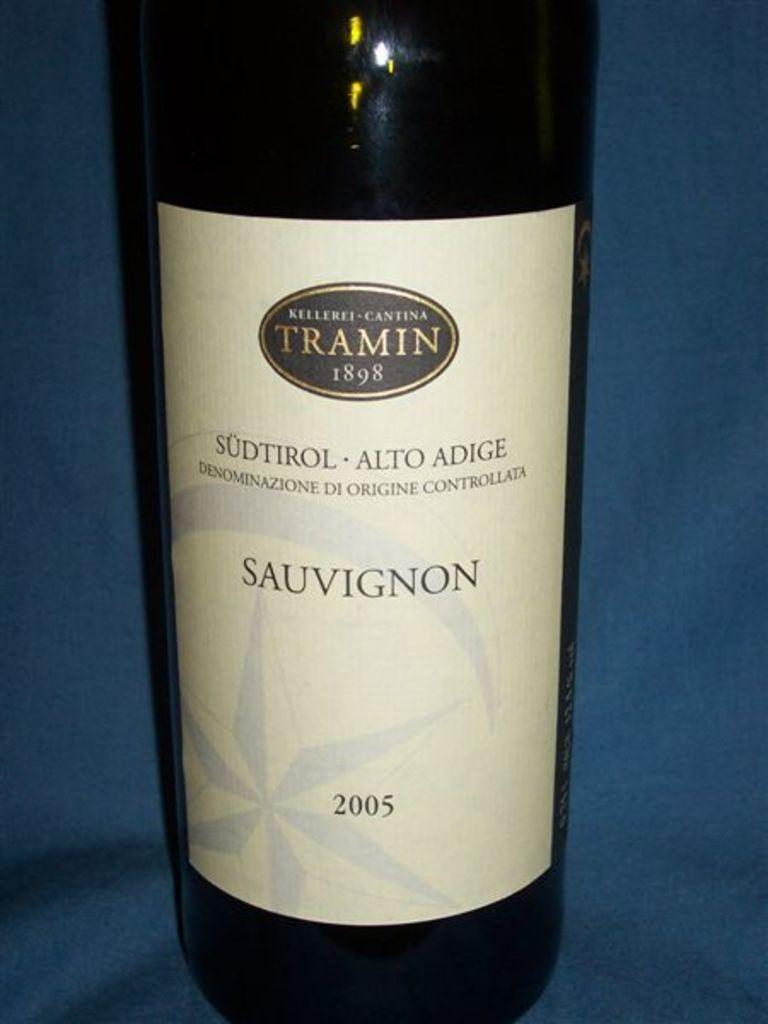<image>
Present a compact description of the photo's key features. A bottle of 2005 TRAMIN 1898 SAUVIGNON is pictured. 